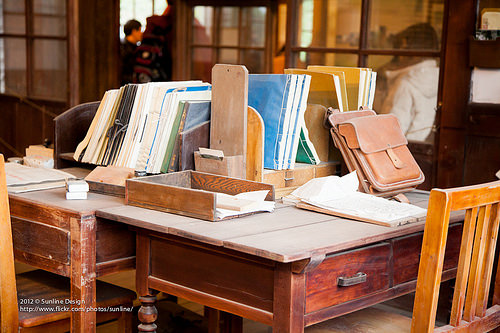<image>
Is the book on the table? Yes. Looking at the image, I can see the book is positioned on top of the table, with the table providing support. Is there a book in the box? No. The book is not contained within the box. These objects have a different spatial relationship. 